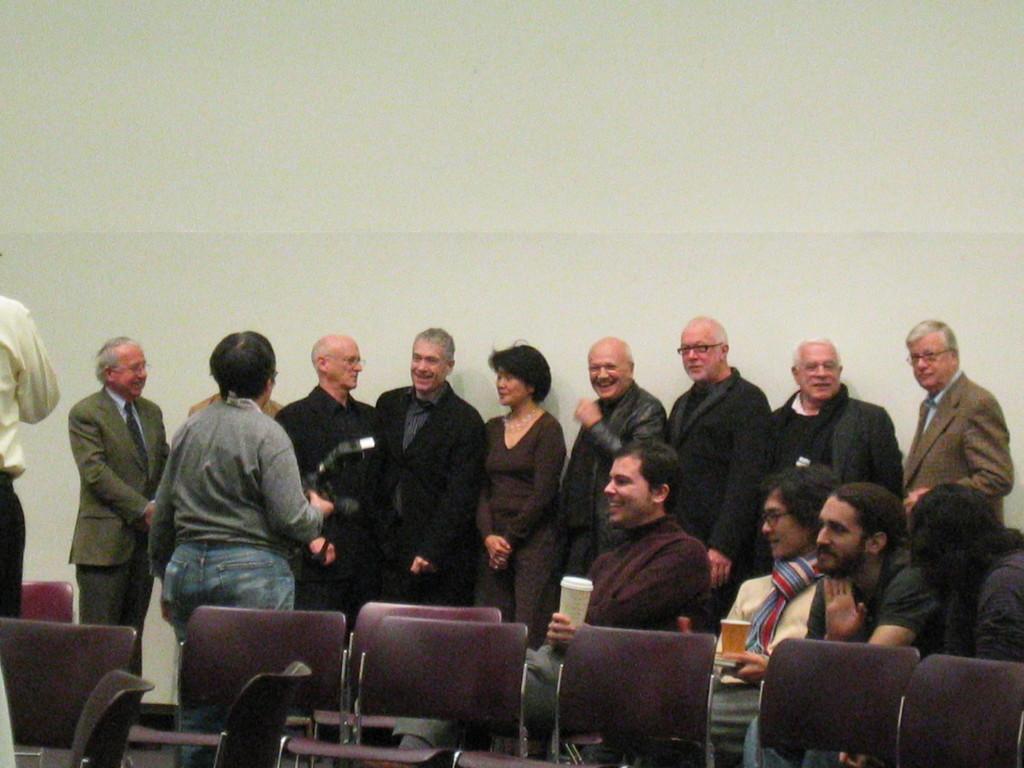Describe this image in one or two sentences. In the picture I can see four persons sitting in the right corner and there are few other persons standing behind them and there is a person standing and holding a camera in his hands in front of them and there is another person standing in the left corner. 